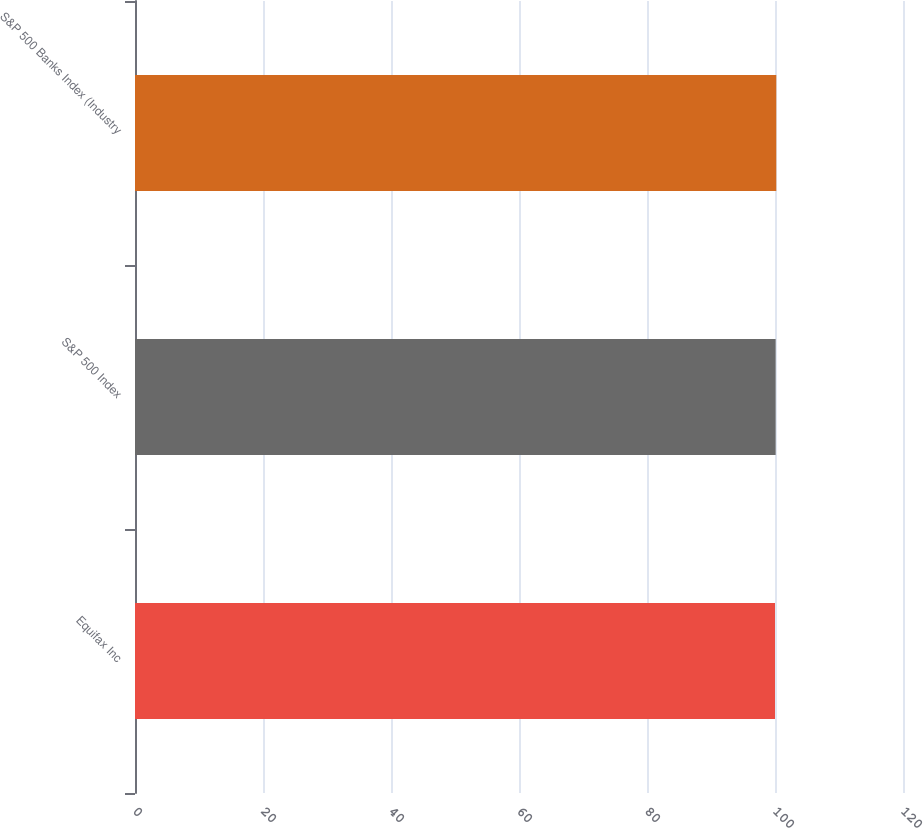Convert chart to OTSL. <chart><loc_0><loc_0><loc_500><loc_500><bar_chart><fcel>Equifax Inc<fcel>S&P 500 Index<fcel>S&P 500 Banks Index (Industry<nl><fcel>100<fcel>100.1<fcel>100.2<nl></chart> 